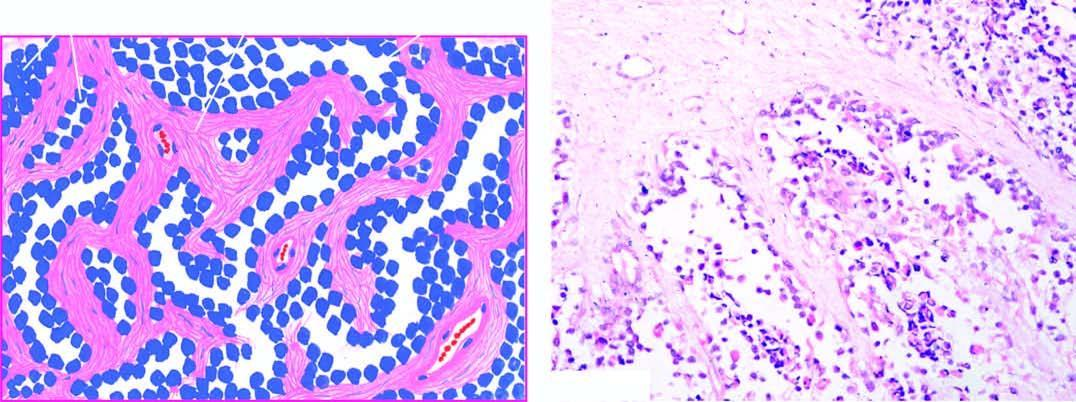what is divided into alveolar spaces composed of fibrocollagenous tissue?
Answer the question using a single word or phrase. Tumour 